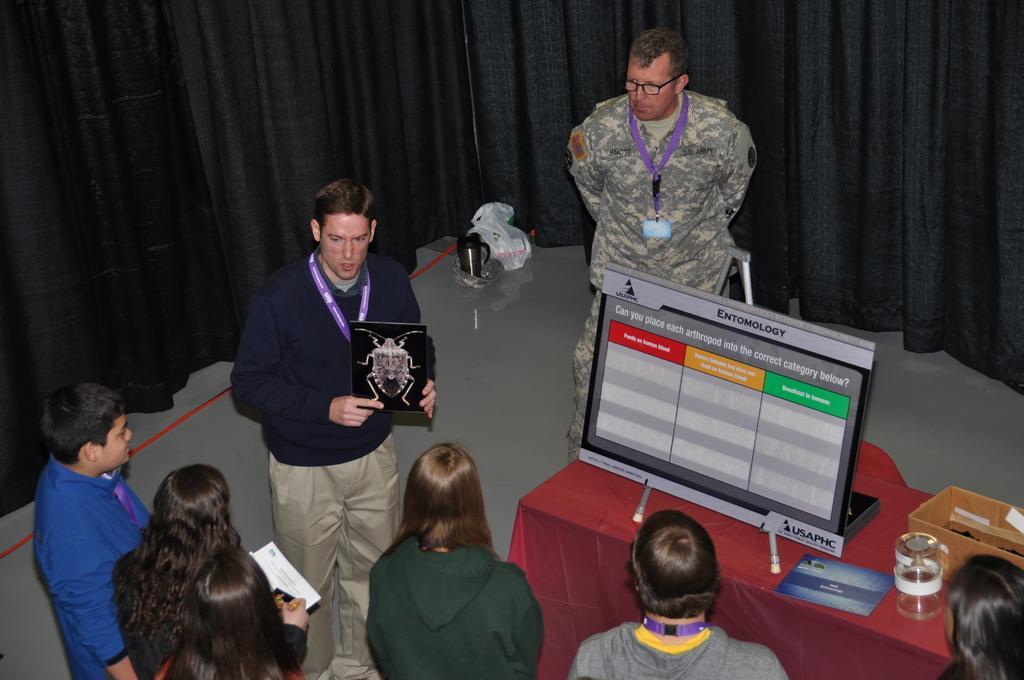Describe this image in one or two sentences. There is a group of persons standing as we can see at the bottom of this image. The person standing in the middle is holding an object. There is a desktop and some other objects are kept on a table is on the right side of this image, and there is a black color curtain in the background. 